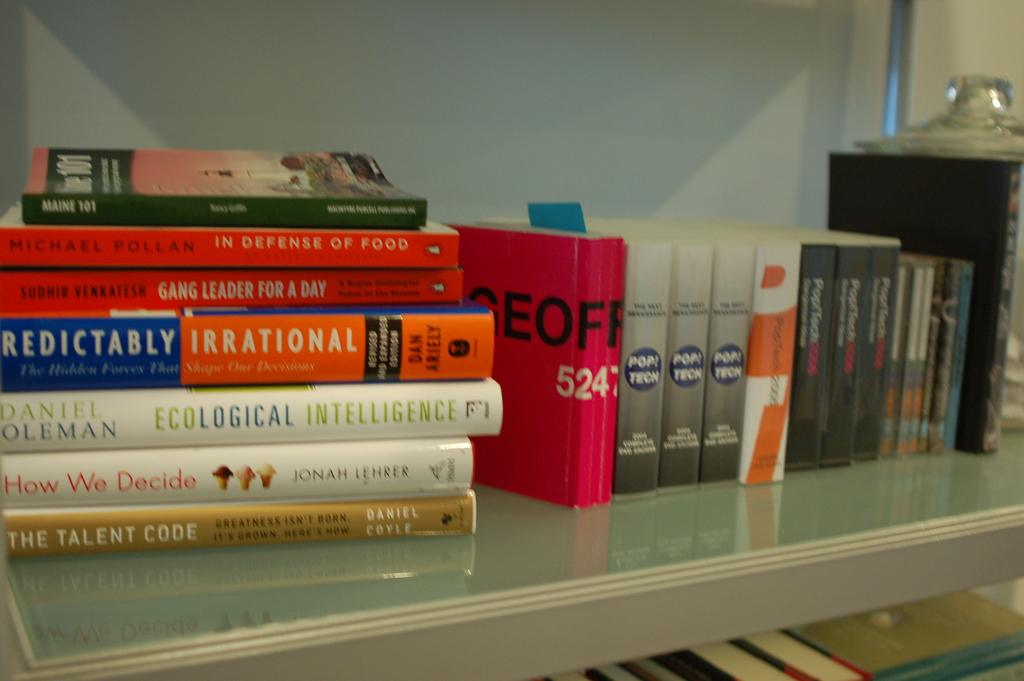<image>
Render a clear and concise summary of the photo. a book with the words talent code at the end 